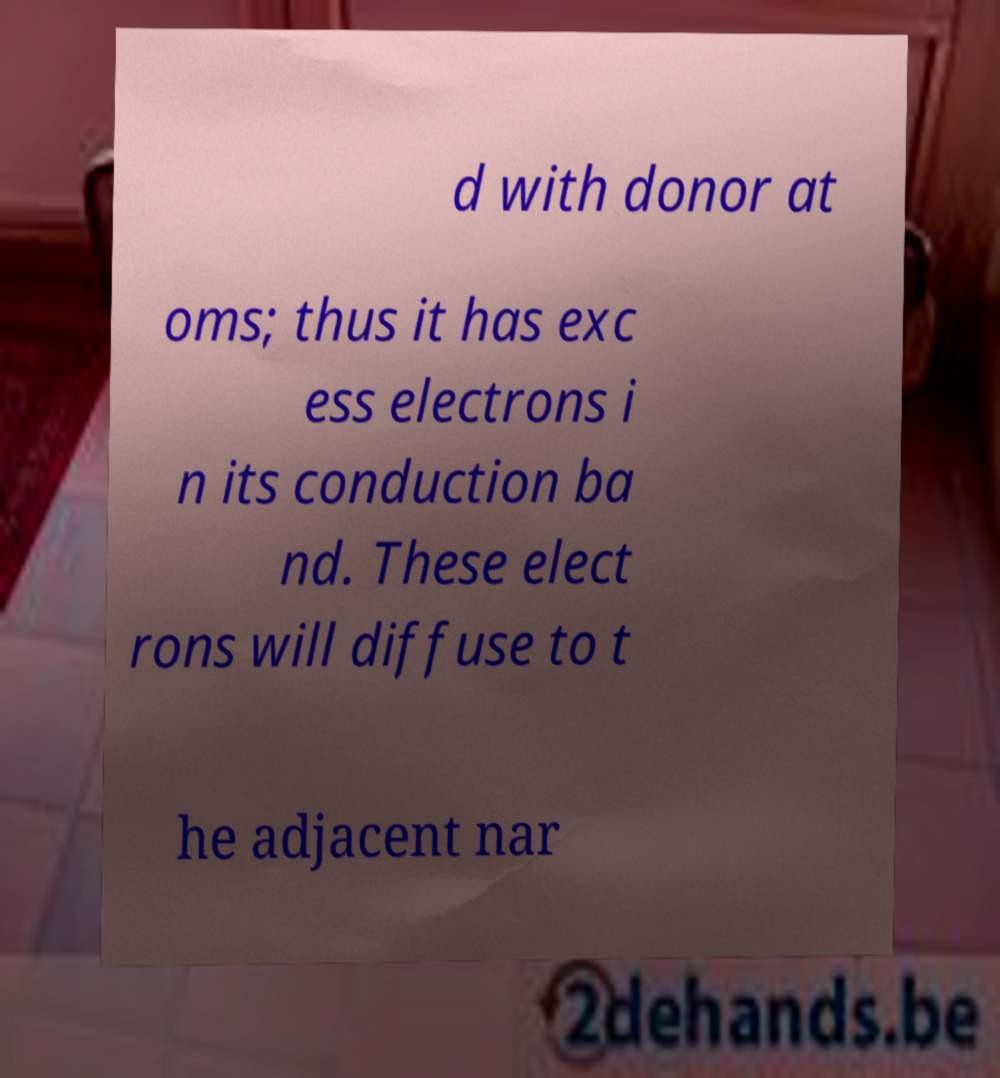Can you read and provide the text displayed in the image?This photo seems to have some interesting text. Can you extract and type it out for me? d with donor at oms; thus it has exc ess electrons i n its conduction ba nd. These elect rons will diffuse to t he adjacent nar 